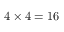<formula> <loc_0><loc_0><loc_500><loc_500>4 \times 4 = 1 6</formula> 